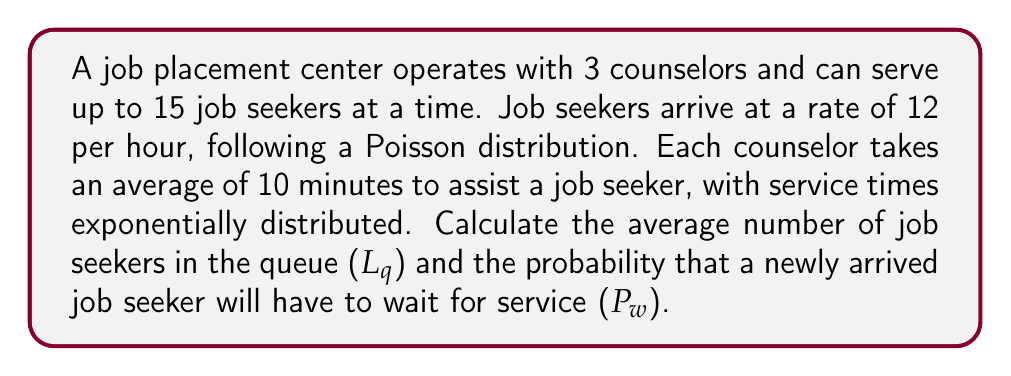Give your solution to this math problem. To solve this problem, we'll use the M/M/s/K queuing model, where:
M = Poisson arrival and exponential service times
s = number of servers (counselors)
K = system capacity

Step 1: Calculate arrival and service rates
Arrival rate: λ = 12 per hour
Service rate: μ = 6 per hour (60 minutes / 10 minutes per job seeker)

Step 2: Calculate traffic intensity
ρ = λ / (s * μ) = 12 / (3 * 6) = 2/3

Step 3: Calculate p0 (probability of an empty system)
$$ p_0 = \left[\sum_{n=0}^{s-1}\frac{(s\rho)^n}{n!} + \frac{(s\rho)^s}{s!}\frac{1-\rho^{K-s+1}}{1-\rho}\right]^{-1} $$

Using a calculator or computer, we find p0 ≈ 0.0132

Step 4: Calculate Lq (average number in queue)
$$ L_q = \frac{p_0(s\rho)^s\rho}{s!(1-\rho)^2}\left[1-\rho^{K-s+1}-\left(1-\rho\right)(K-s+1)\rho^{K-s}\right] $$

Substituting the values, we get Lq ≈ 0.6815

Step 5: Calculate Pw (probability of waiting)
$$ P_w = \frac{p_0(s\rho)^s}{s!(1-\rho)}\left[1-\rho^{K-s+1}\right] $$

Substituting the values, we get Pw ≈ 0.3407 or 34.07%
Answer: Lq ≈ 0.6815, Pw ≈ 34.07% 